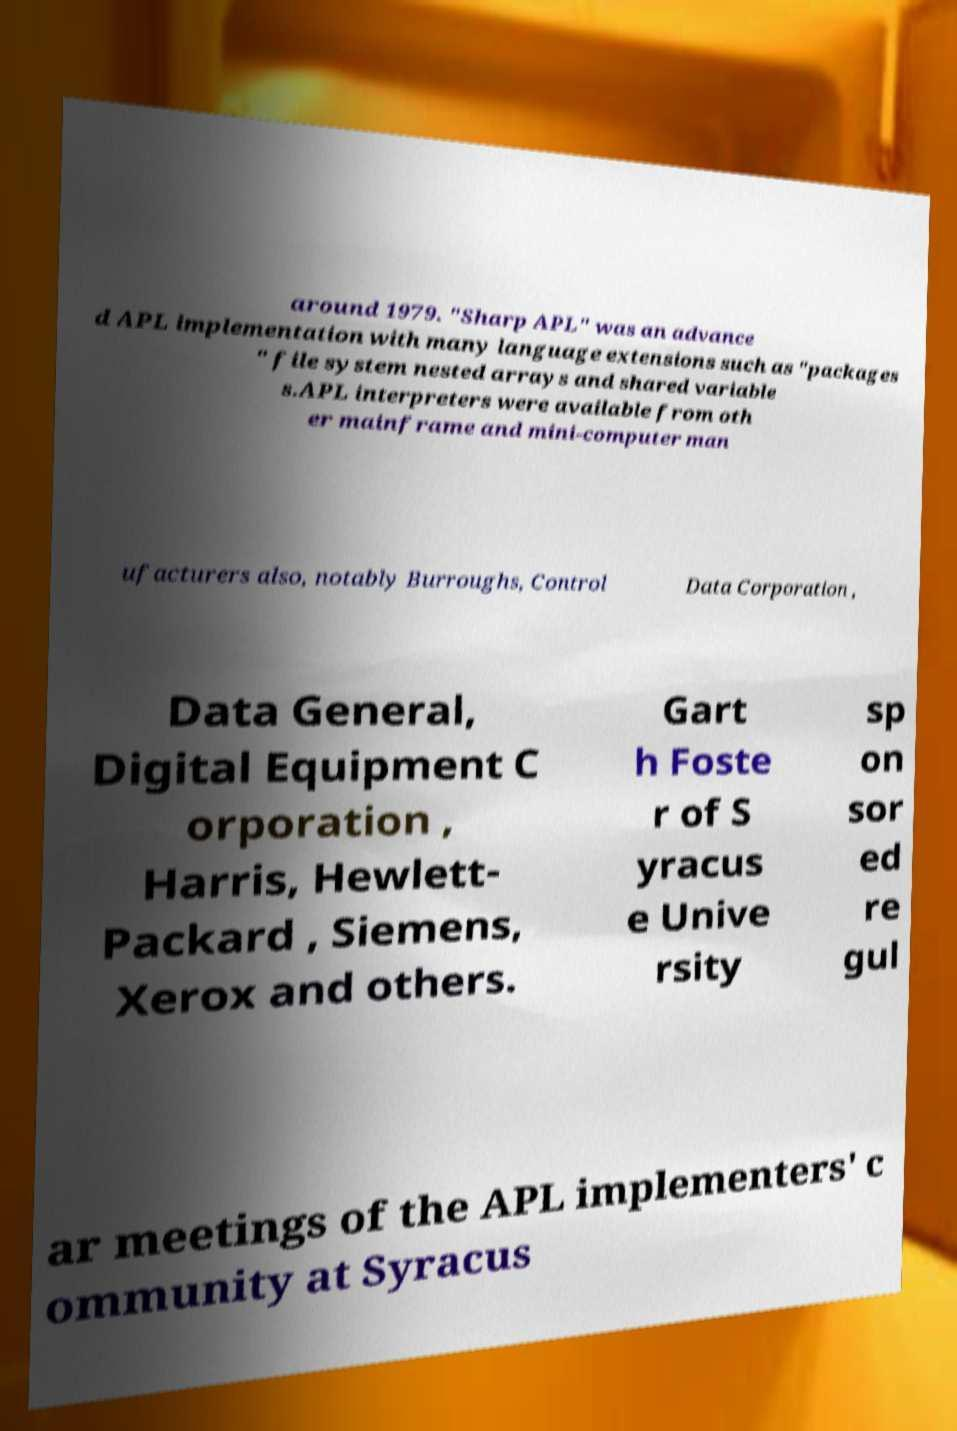I need the written content from this picture converted into text. Can you do that? around 1979. "Sharp APL" was an advance d APL implementation with many language extensions such as "packages " file system nested arrays and shared variable s.APL interpreters were available from oth er mainframe and mini-computer man ufacturers also, notably Burroughs, Control Data Corporation , Data General, Digital Equipment C orporation , Harris, Hewlett- Packard , Siemens, Xerox and others. Gart h Foste r of S yracus e Unive rsity sp on sor ed re gul ar meetings of the APL implementers' c ommunity at Syracus 